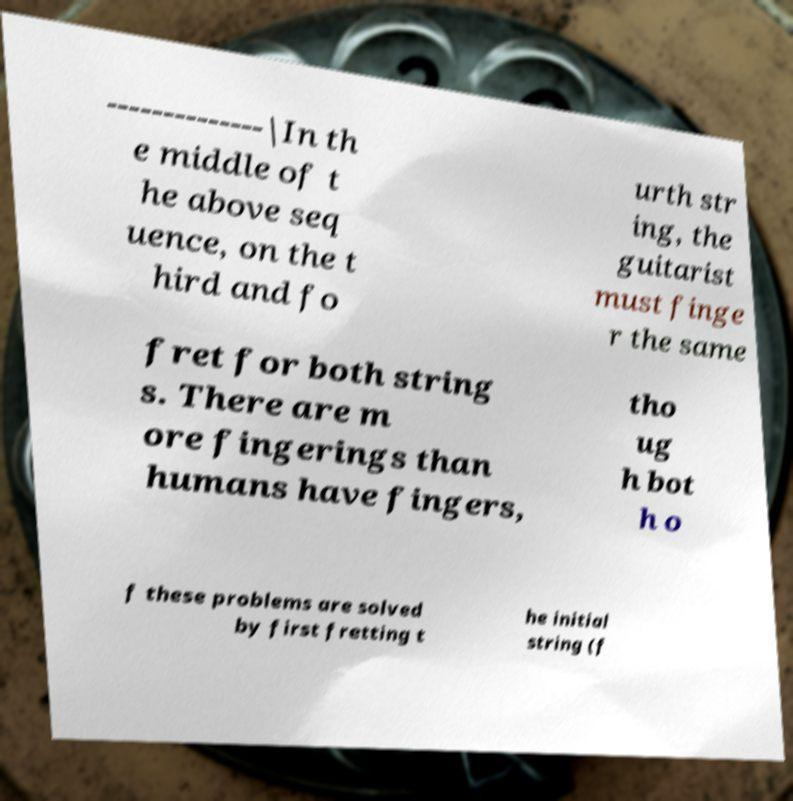Please identify and transcribe the text found in this image. --------------|In th e middle of t he above seq uence, on the t hird and fo urth str ing, the guitarist must finge r the same fret for both string s. There are m ore fingerings than humans have fingers, tho ug h bot h o f these problems are solved by first fretting t he initial string (f 